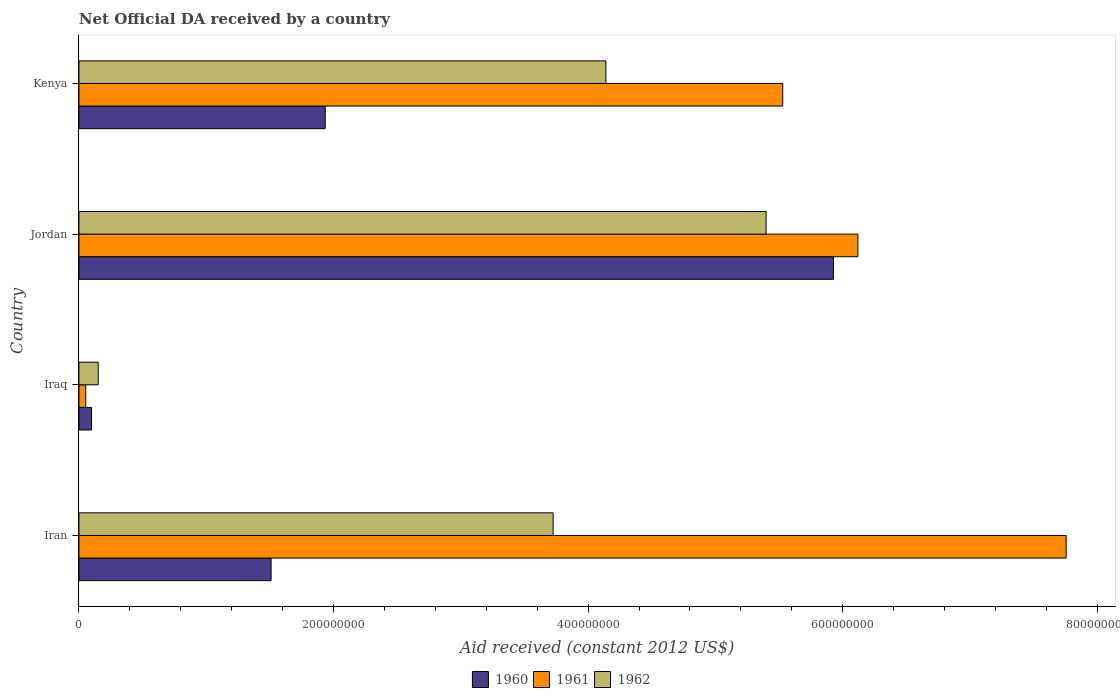How many different coloured bars are there?
Your answer should be compact. 3. How many bars are there on the 4th tick from the top?
Give a very brief answer. 3. How many bars are there on the 4th tick from the bottom?
Give a very brief answer. 3. What is the label of the 2nd group of bars from the top?
Your answer should be compact. Jordan. What is the net official development assistance aid received in 1960 in Kenya?
Keep it short and to the point. 1.93e+08. Across all countries, what is the maximum net official development assistance aid received in 1962?
Provide a short and direct response. 5.40e+08. Across all countries, what is the minimum net official development assistance aid received in 1960?
Offer a terse response. 9.91e+06. In which country was the net official development assistance aid received in 1961 maximum?
Make the answer very short. Iran. In which country was the net official development assistance aid received in 1962 minimum?
Keep it short and to the point. Iraq. What is the total net official development assistance aid received in 1960 in the graph?
Keep it short and to the point. 9.47e+08. What is the difference between the net official development assistance aid received in 1960 in Jordan and that in Kenya?
Keep it short and to the point. 3.99e+08. What is the difference between the net official development assistance aid received in 1962 in Iraq and the net official development assistance aid received in 1960 in Iran?
Provide a succinct answer. -1.36e+08. What is the average net official development assistance aid received in 1961 per country?
Ensure brevity in your answer.  4.86e+08. What is the difference between the net official development assistance aid received in 1962 and net official development assistance aid received in 1961 in Iran?
Make the answer very short. -4.03e+08. What is the ratio of the net official development assistance aid received in 1961 in Iran to that in Iraq?
Offer a very short reply. 145.49. What is the difference between the highest and the second highest net official development assistance aid received in 1962?
Your answer should be very brief. 1.26e+08. What is the difference between the highest and the lowest net official development assistance aid received in 1960?
Give a very brief answer. 5.83e+08. How many bars are there?
Give a very brief answer. 12. What is the difference between two consecutive major ticks on the X-axis?
Offer a terse response. 2.00e+08. Are the values on the major ticks of X-axis written in scientific E-notation?
Your answer should be very brief. No. Does the graph contain grids?
Make the answer very short. No. Where does the legend appear in the graph?
Your answer should be compact. Bottom center. How many legend labels are there?
Keep it short and to the point. 3. What is the title of the graph?
Provide a succinct answer. Net Official DA received by a country. What is the label or title of the X-axis?
Ensure brevity in your answer.  Aid received (constant 2012 US$). What is the label or title of the Y-axis?
Your answer should be compact. Country. What is the Aid received (constant 2012 US$) in 1960 in Iran?
Offer a very short reply. 1.51e+08. What is the Aid received (constant 2012 US$) of 1961 in Iran?
Give a very brief answer. 7.75e+08. What is the Aid received (constant 2012 US$) of 1962 in Iran?
Give a very brief answer. 3.73e+08. What is the Aid received (constant 2012 US$) of 1960 in Iraq?
Make the answer very short. 9.91e+06. What is the Aid received (constant 2012 US$) in 1961 in Iraq?
Ensure brevity in your answer.  5.33e+06. What is the Aid received (constant 2012 US$) in 1962 in Iraq?
Your answer should be very brief. 1.51e+07. What is the Aid received (constant 2012 US$) in 1960 in Jordan?
Keep it short and to the point. 5.93e+08. What is the Aid received (constant 2012 US$) of 1961 in Jordan?
Make the answer very short. 6.12e+08. What is the Aid received (constant 2012 US$) of 1962 in Jordan?
Offer a very short reply. 5.40e+08. What is the Aid received (constant 2012 US$) of 1960 in Kenya?
Your response must be concise. 1.93e+08. What is the Aid received (constant 2012 US$) of 1961 in Kenya?
Keep it short and to the point. 5.53e+08. What is the Aid received (constant 2012 US$) in 1962 in Kenya?
Keep it short and to the point. 4.14e+08. Across all countries, what is the maximum Aid received (constant 2012 US$) in 1960?
Provide a short and direct response. 5.93e+08. Across all countries, what is the maximum Aid received (constant 2012 US$) of 1961?
Give a very brief answer. 7.75e+08. Across all countries, what is the maximum Aid received (constant 2012 US$) in 1962?
Ensure brevity in your answer.  5.40e+08. Across all countries, what is the minimum Aid received (constant 2012 US$) in 1960?
Keep it short and to the point. 9.91e+06. Across all countries, what is the minimum Aid received (constant 2012 US$) in 1961?
Give a very brief answer. 5.33e+06. Across all countries, what is the minimum Aid received (constant 2012 US$) of 1962?
Your response must be concise. 1.51e+07. What is the total Aid received (constant 2012 US$) in 1960 in the graph?
Offer a very short reply. 9.47e+08. What is the total Aid received (constant 2012 US$) in 1961 in the graph?
Ensure brevity in your answer.  1.95e+09. What is the total Aid received (constant 2012 US$) in 1962 in the graph?
Your answer should be very brief. 1.34e+09. What is the difference between the Aid received (constant 2012 US$) in 1960 in Iran and that in Iraq?
Your answer should be compact. 1.41e+08. What is the difference between the Aid received (constant 2012 US$) in 1961 in Iran and that in Iraq?
Make the answer very short. 7.70e+08. What is the difference between the Aid received (constant 2012 US$) of 1962 in Iran and that in Iraq?
Give a very brief answer. 3.57e+08. What is the difference between the Aid received (constant 2012 US$) in 1960 in Iran and that in Jordan?
Provide a succinct answer. -4.42e+08. What is the difference between the Aid received (constant 2012 US$) in 1961 in Iran and that in Jordan?
Provide a short and direct response. 1.64e+08. What is the difference between the Aid received (constant 2012 US$) of 1962 in Iran and that in Jordan?
Ensure brevity in your answer.  -1.67e+08. What is the difference between the Aid received (constant 2012 US$) of 1960 in Iran and that in Kenya?
Provide a short and direct response. -4.25e+07. What is the difference between the Aid received (constant 2012 US$) of 1961 in Iran and that in Kenya?
Offer a very short reply. 2.23e+08. What is the difference between the Aid received (constant 2012 US$) in 1962 in Iran and that in Kenya?
Offer a very short reply. -4.14e+07. What is the difference between the Aid received (constant 2012 US$) of 1960 in Iraq and that in Jordan?
Give a very brief answer. -5.83e+08. What is the difference between the Aid received (constant 2012 US$) in 1961 in Iraq and that in Jordan?
Offer a very short reply. -6.07e+08. What is the difference between the Aid received (constant 2012 US$) of 1962 in Iraq and that in Jordan?
Give a very brief answer. -5.25e+08. What is the difference between the Aid received (constant 2012 US$) in 1960 in Iraq and that in Kenya?
Provide a short and direct response. -1.84e+08. What is the difference between the Aid received (constant 2012 US$) of 1961 in Iraq and that in Kenya?
Your response must be concise. -5.48e+08. What is the difference between the Aid received (constant 2012 US$) in 1962 in Iraq and that in Kenya?
Give a very brief answer. -3.99e+08. What is the difference between the Aid received (constant 2012 US$) of 1960 in Jordan and that in Kenya?
Your response must be concise. 3.99e+08. What is the difference between the Aid received (constant 2012 US$) of 1961 in Jordan and that in Kenya?
Your answer should be very brief. 5.91e+07. What is the difference between the Aid received (constant 2012 US$) of 1962 in Jordan and that in Kenya?
Make the answer very short. 1.26e+08. What is the difference between the Aid received (constant 2012 US$) of 1960 in Iran and the Aid received (constant 2012 US$) of 1961 in Iraq?
Your response must be concise. 1.46e+08. What is the difference between the Aid received (constant 2012 US$) of 1960 in Iran and the Aid received (constant 2012 US$) of 1962 in Iraq?
Your answer should be compact. 1.36e+08. What is the difference between the Aid received (constant 2012 US$) in 1961 in Iran and the Aid received (constant 2012 US$) in 1962 in Iraq?
Provide a short and direct response. 7.60e+08. What is the difference between the Aid received (constant 2012 US$) in 1960 in Iran and the Aid received (constant 2012 US$) in 1961 in Jordan?
Ensure brevity in your answer.  -4.61e+08. What is the difference between the Aid received (constant 2012 US$) in 1960 in Iran and the Aid received (constant 2012 US$) in 1962 in Jordan?
Provide a short and direct response. -3.89e+08. What is the difference between the Aid received (constant 2012 US$) of 1961 in Iran and the Aid received (constant 2012 US$) of 1962 in Jordan?
Your answer should be compact. 2.36e+08. What is the difference between the Aid received (constant 2012 US$) of 1960 in Iran and the Aid received (constant 2012 US$) of 1961 in Kenya?
Provide a succinct answer. -4.02e+08. What is the difference between the Aid received (constant 2012 US$) of 1960 in Iran and the Aid received (constant 2012 US$) of 1962 in Kenya?
Provide a short and direct response. -2.63e+08. What is the difference between the Aid received (constant 2012 US$) of 1961 in Iran and the Aid received (constant 2012 US$) of 1962 in Kenya?
Provide a short and direct response. 3.62e+08. What is the difference between the Aid received (constant 2012 US$) in 1960 in Iraq and the Aid received (constant 2012 US$) in 1961 in Jordan?
Keep it short and to the point. -6.02e+08. What is the difference between the Aid received (constant 2012 US$) in 1960 in Iraq and the Aid received (constant 2012 US$) in 1962 in Jordan?
Ensure brevity in your answer.  -5.30e+08. What is the difference between the Aid received (constant 2012 US$) of 1961 in Iraq and the Aid received (constant 2012 US$) of 1962 in Jordan?
Give a very brief answer. -5.34e+08. What is the difference between the Aid received (constant 2012 US$) in 1960 in Iraq and the Aid received (constant 2012 US$) in 1961 in Kenya?
Offer a terse response. -5.43e+08. What is the difference between the Aid received (constant 2012 US$) in 1960 in Iraq and the Aid received (constant 2012 US$) in 1962 in Kenya?
Your answer should be compact. -4.04e+08. What is the difference between the Aid received (constant 2012 US$) of 1961 in Iraq and the Aid received (constant 2012 US$) of 1962 in Kenya?
Your answer should be very brief. -4.09e+08. What is the difference between the Aid received (constant 2012 US$) of 1960 in Jordan and the Aid received (constant 2012 US$) of 1961 in Kenya?
Offer a terse response. 3.98e+07. What is the difference between the Aid received (constant 2012 US$) of 1960 in Jordan and the Aid received (constant 2012 US$) of 1962 in Kenya?
Your answer should be compact. 1.79e+08. What is the difference between the Aid received (constant 2012 US$) in 1961 in Jordan and the Aid received (constant 2012 US$) in 1962 in Kenya?
Give a very brief answer. 1.98e+08. What is the average Aid received (constant 2012 US$) in 1960 per country?
Your answer should be very brief. 2.37e+08. What is the average Aid received (constant 2012 US$) in 1961 per country?
Provide a succinct answer. 4.86e+08. What is the average Aid received (constant 2012 US$) of 1962 per country?
Give a very brief answer. 3.35e+08. What is the difference between the Aid received (constant 2012 US$) of 1960 and Aid received (constant 2012 US$) of 1961 in Iran?
Offer a very short reply. -6.25e+08. What is the difference between the Aid received (constant 2012 US$) of 1960 and Aid received (constant 2012 US$) of 1962 in Iran?
Offer a terse response. -2.22e+08. What is the difference between the Aid received (constant 2012 US$) of 1961 and Aid received (constant 2012 US$) of 1962 in Iran?
Provide a short and direct response. 4.03e+08. What is the difference between the Aid received (constant 2012 US$) of 1960 and Aid received (constant 2012 US$) of 1961 in Iraq?
Provide a short and direct response. 4.58e+06. What is the difference between the Aid received (constant 2012 US$) in 1960 and Aid received (constant 2012 US$) in 1962 in Iraq?
Provide a short and direct response. -5.22e+06. What is the difference between the Aid received (constant 2012 US$) in 1961 and Aid received (constant 2012 US$) in 1962 in Iraq?
Provide a succinct answer. -9.80e+06. What is the difference between the Aid received (constant 2012 US$) of 1960 and Aid received (constant 2012 US$) of 1961 in Jordan?
Provide a short and direct response. -1.92e+07. What is the difference between the Aid received (constant 2012 US$) in 1960 and Aid received (constant 2012 US$) in 1962 in Jordan?
Your response must be concise. 5.29e+07. What is the difference between the Aid received (constant 2012 US$) in 1961 and Aid received (constant 2012 US$) in 1962 in Jordan?
Keep it short and to the point. 7.21e+07. What is the difference between the Aid received (constant 2012 US$) of 1960 and Aid received (constant 2012 US$) of 1961 in Kenya?
Provide a succinct answer. -3.59e+08. What is the difference between the Aid received (constant 2012 US$) in 1960 and Aid received (constant 2012 US$) in 1962 in Kenya?
Keep it short and to the point. -2.20e+08. What is the difference between the Aid received (constant 2012 US$) of 1961 and Aid received (constant 2012 US$) of 1962 in Kenya?
Provide a succinct answer. 1.39e+08. What is the ratio of the Aid received (constant 2012 US$) of 1960 in Iran to that in Iraq?
Offer a very short reply. 15.23. What is the ratio of the Aid received (constant 2012 US$) in 1961 in Iran to that in Iraq?
Make the answer very short. 145.49. What is the ratio of the Aid received (constant 2012 US$) in 1962 in Iran to that in Iraq?
Offer a terse response. 24.62. What is the ratio of the Aid received (constant 2012 US$) of 1960 in Iran to that in Jordan?
Your response must be concise. 0.25. What is the ratio of the Aid received (constant 2012 US$) in 1961 in Iran to that in Jordan?
Make the answer very short. 1.27. What is the ratio of the Aid received (constant 2012 US$) of 1962 in Iran to that in Jordan?
Ensure brevity in your answer.  0.69. What is the ratio of the Aid received (constant 2012 US$) in 1960 in Iran to that in Kenya?
Provide a succinct answer. 0.78. What is the ratio of the Aid received (constant 2012 US$) in 1961 in Iran to that in Kenya?
Keep it short and to the point. 1.4. What is the ratio of the Aid received (constant 2012 US$) in 1962 in Iran to that in Kenya?
Offer a terse response. 0.9. What is the ratio of the Aid received (constant 2012 US$) in 1960 in Iraq to that in Jordan?
Offer a terse response. 0.02. What is the ratio of the Aid received (constant 2012 US$) in 1961 in Iraq to that in Jordan?
Your response must be concise. 0.01. What is the ratio of the Aid received (constant 2012 US$) in 1962 in Iraq to that in Jordan?
Provide a short and direct response. 0.03. What is the ratio of the Aid received (constant 2012 US$) in 1960 in Iraq to that in Kenya?
Make the answer very short. 0.05. What is the ratio of the Aid received (constant 2012 US$) in 1961 in Iraq to that in Kenya?
Your answer should be very brief. 0.01. What is the ratio of the Aid received (constant 2012 US$) in 1962 in Iraq to that in Kenya?
Your answer should be very brief. 0.04. What is the ratio of the Aid received (constant 2012 US$) of 1960 in Jordan to that in Kenya?
Give a very brief answer. 3.06. What is the ratio of the Aid received (constant 2012 US$) of 1961 in Jordan to that in Kenya?
Give a very brief answer. 1.11. What is the ratio of the Aid received (constant 2012 US$) in 1962 in Jordan to that in Kenya?
Your answer should be very brief. 1.3. What is the difference between the highest and the second highest Aid received (constant 2012 US$) of 1960?
Your answer should be very brief. 3.99e+08. What is the difference between the highest and the second highest Aid received (constant 2012 US$) in 1961?
Your answer should be compact. 1.64e+08. What is the difference between the highest and the second highest Aid received (constant 2012 US$) of 1962?
Your answer should be very brief. 1.26e+08. What is the difference between the highest and the lowest Aid received (constant 2012 US$) of 1960?
Provide a short and direct response. 5.83e+08. What is the difference between the highest and the lowest Aid received (constant 2012 US$) of 1961?
Provide a succinct answer. 7.70e+08. What is the difference between the highest and the lowest Aid received (constant 2012 US$) of 1962?
Your answer should be very brief. 5.25e+08. 